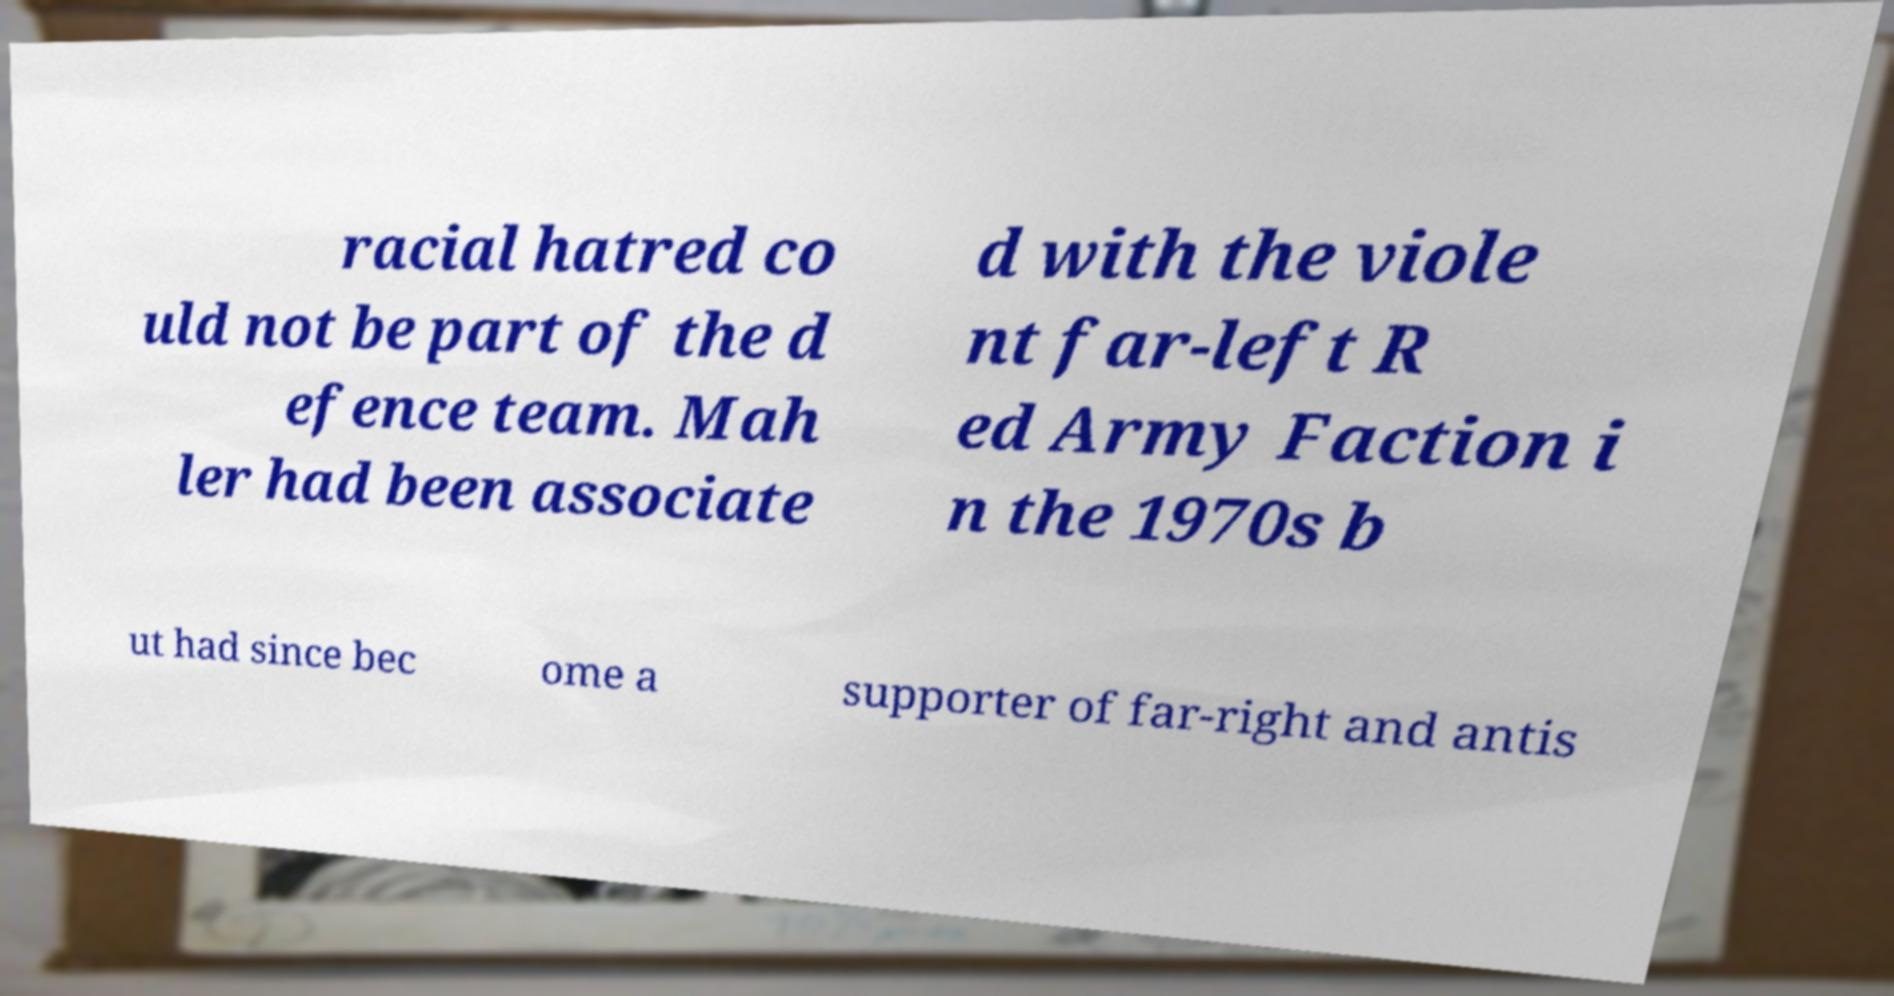Can you read and provide the text displayed in the image?This photo seems to have some interesting text. Can you extract and type it out for me? racial hatred co uld not be part of the d efence team. Mah ler had been associate d with the viole nt far-left R ed Army Faction i n the 1970s b ut had since bec ome a supporter of far-right and antis 